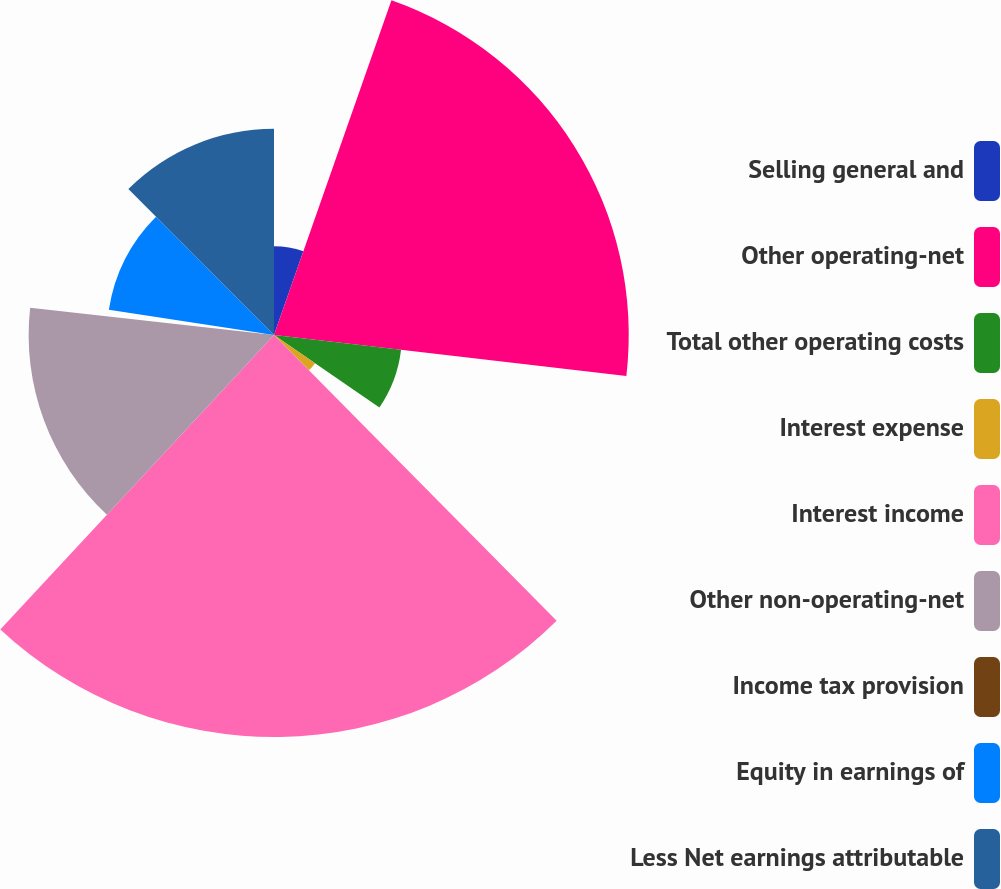Convert chart. <chart><loc_0><loc_0><loc_500><loc_500><pie_chart><fcel>Selling general and<fcel>Other operating-net<fcel>Total other operating costs<fcel>Interest expense<fcel>Interest income<fcel>Other non-operating-net<fcel>Income tax provision<fcel>Equity in earnings of<fcel>Less Net earnings attributable<nl><fcel>5.37%<fcel>21.47%<fcel>7.74%<fcel>3.01%<fcel>24.33%<fcel>14.85%<fcel>0.64%<fcel>10.11%<fcel>12.48%<nl></chart> 